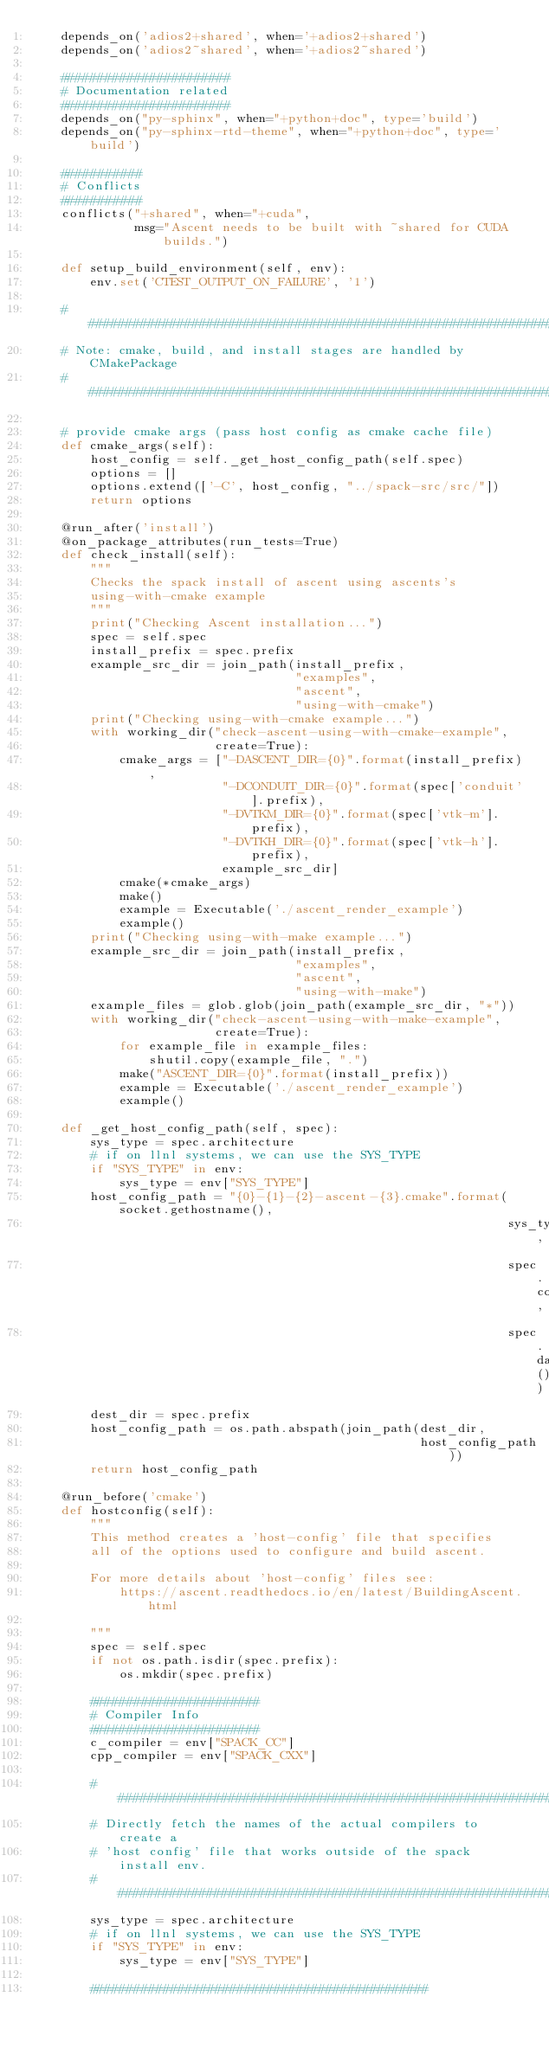Convert code to text. <code><loc_0><loc_0><loc_500><loc_500><_Python_>    depends_on('adios2+shared', when='+adios2+shared')
    depends_on('adios2~shared', when='+adios2~shared')

    #######################
    # Documentation related
    #######################
    depends_on("py-sphinx", when="+python+doc", type='build')
    depends_on("py-sphinx-rtd-theme", when="+python+doc", type='build')

    ###########
    # Conflicts
    ###########
    conflicts("+shared", when="+cuda",
              msg="Ascent needs to be built with ~shared for CUDA builds.")

    def setup_build_environment(self, env):
        env.set('CTEST_OUTPUT_ON_FAILURE', '1')

    ####################################################################
    # Note: cmake, build, and install stages are handled by CMakePackage
    ####################################################################

    # provide cmake args (pass host config as cmake cache file)
    def cmake_args(self):
        host_config = self._get_host_config_path(self.spec)
        options = []
        options.extend(['-C', host_config, "../spack-src/src/"])
        return options

    @run_after('install')
    @on_package_attributes(run_tests=True)
    def check_install(self):
        """
        Checks the spack install of ascent using ascents's
        using-with-cmake example
        """
        print("Checking Ascent installation...")
        spec = self.spec
        install_prefix = spec.prefix
        example_src_dir = join_path(install_prefix,
                                    "examples",
                                    "ascent",
                                    "using-with-cmake")
        print("Checking using-with-cmake example...")
        with working_dir("check-ascent-using-with-cmake-example",
                         create=True):
            cmake_args = ["-DASCENT_DIR={0}".format(install_prefix),
                          "-DCONDUIT_DIR={0}".format(spec['conduit'].prefix),
                          "-DVTKM_DIR={0}".format(spec['vtk-m'].prefix),
                          "-DVTKH_DIR={0}".format(spec['vtk-h'].prefix),
                          example_src_dir]
            cmake(*cmake_args)
            make()
            example = Executable('./ascent_render_example')
            example()
        print("Checking using-with-make example...")
        example_src_dir = join_path(install_prefix,
                                    "examples",
                                    "ascent",
                                    "using-with-make")
        example_files = glob.glob(join_path(example_src_dir, "*"))
        with working_dir("check-ascent-using-with-make-example",
                         create=True):
            for example_file in example_files:
                shutil.copy(example_file, ".")
            make("ASCENT_DIR={0}".format(install_prefix))
            example = Executable('./ascent_render_example')
            example()

    def _get_host_config_path(self, spec):
        sys_type = spec.architecture
        # if on llnl systems, we can use the SYS_TYPE
        if "SYS_TYPE" in env:
            sys_type = env["SYS_TYPE"]
        host_config_path = "{0}-{1}-{2}-ascent-{3}.cmake".format(socket.gethostname(),
                                                                 sys_type,
                                                                 spec.compiler,
                                                                 spec.dag_hash())
        dest_dir = spec.prefix
        host_config_path = os.path.abspath(join_path(dest_dir,
                                                     host_config_path))
        return host_config_path

    @run_before('cmake')
    def hostconfig(self):
        """
        This method creates a 'host-config' file that specifies
        all of the options used to configure and build ascent.

        For more details about 'host-config' files see:
            https://ascent.readthedocs.io/en/latest/BuildingAscent.html

        """
        spec = self.spec
        if not os.path.isdir(spec.prefix):
            os.mkdir(spec.prefix)

        #######################
        # Compiler Info
        #######################
        c_compiler = env["SPACK_CC"]
        cpp_compiler = env["SPACK_CXX"]

        #######################################################################
        # Directly fetch the names of the actual compilers to create a
        # 'host config' file that works outside of the spack install env.
        #######################################################################
        sys_type = spec.architecture
        # if on llnl systems, we can use the SYS_TYPE
        if "SYS_TYPE" in env:
            sys_type = env["SYS_TYPE"]

        ##############################################</code> 